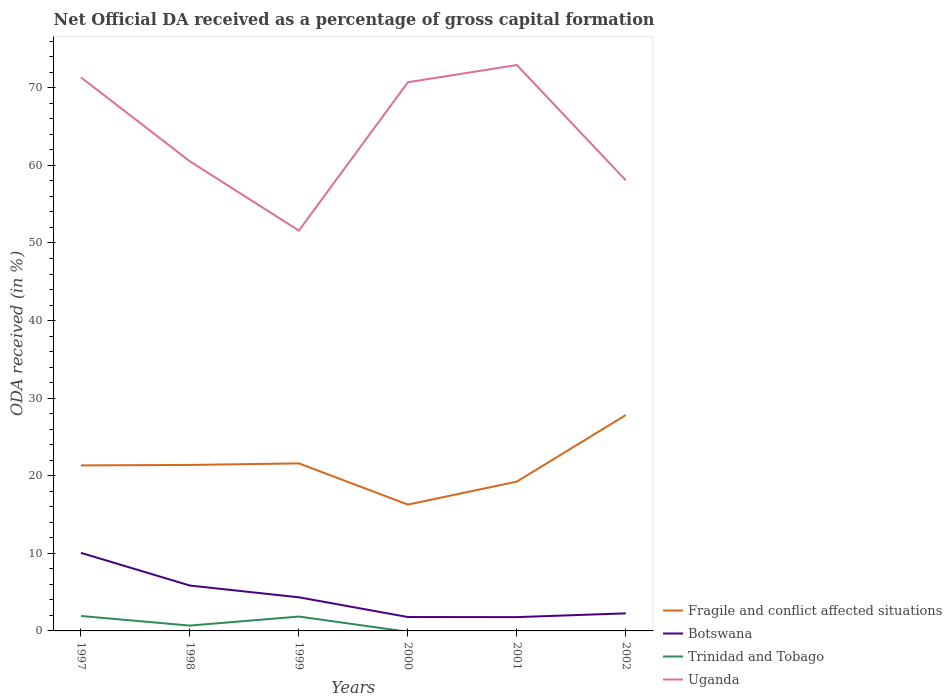How many different coloured lines are there?
Offer a terse response. 4. Across all years, what is the maximum net ODA received in Fragile and conflict affected situations?
Your response must be concise. 16.28. What is the total net ODA received in Uganda in the graph?
Keep it short and to the point. 14.86. What is the difference between the highest and the second highest net ODA received in Botswana?
Make the answer very short. 8.28. What is the difference between the highest and the lowest net ODA received in Trinidad and Tobago?
Your answer should be very brief. 2. How many lines are there?
Make the answer very short. 4. How many years are there in the graph?
Offer a terse response. 6. Does the graph contain grids?
Your answer should be very brief. No. How many legend labels are there?
Provide a succinct answer. 4. What is the title of the graph?
Your response must be concise. Net Official DA received as a percentage of gross capital formation. Does "Europe(developing only)" appear as one of the legend labels in the graph?
Offer a very short reply. No. What is the label or title of the X-axis?
Offer a terse response. Years. What is the label or title of the Y-axis?
Your answer should be compact. ODA received (in %). What is the ODA received (in %) of Fragile and conflict affected situations in 1997?
Offer a very short reply. 21.33. What is the ODA received (in %) in Botswana in 1997?
Provide a short and direct response. 10.06. What is the ODA received (in %) in Trinidad and Tobago in 1997?
Your response must be concise. 1.93. What is the ODA received (in %) of Uganda in 1997?
Your answer should be very brief. 71.34. What is the ODA received (in %) in Fragile and conflict affected situations in 1998?
Provide a short and direct response. 21.39. What is the ODA received (in %) in Botswana in 1998?
Give a very brief answer. 5.85. What is the ODA received (in %) of Trinidad and Tobago in 1998?
Provide a succinct answer. 0.69. What is the ODA received (in %) in Uganda in 1998?
Offer a very short reply. 60.51. What is the ODA received (in %) in Fragile and conflict affected situations in 1999?
Keep it short and to the point. 21.59. What is the ODA received (in %) in Botswana in 1999?
Offer a very short reply. 4.33. What is the ODA received (in %) of Trinidad and Tobago in 1999?
Provide a succinct answer. 1.85. What is the ODA received (in %) of Uganda in 1999?
Provide a short and direct response. 51.59. What is the ODA received (in %) in Fragile and conflict affected situations in 2000?
Keep it short and to the point. 16.28. What is the ODA received (in %) in Botswana in 2000?
Keep it short and to the point. 1.79. What is the ODA received (in %) of Uganda in 2000?
Your answer should be very brief. 70.71. What is the ODA received (in %) of Fragile and conflict affected situations in 2001?
Make the answer very short. 19.24. What is the ODA received (in %) in Botswana in 2001?
Make the answer very short. 1.78. What is the ODA received (in %) in Trinidad and Tobago in 2001?
Your response must be concise. 0. What is the ODA received (in %) in Uganda in 2001?
Keep it short and to the point. 72.93. What is the ODA received (in %) in Fragile and conflict affected situations in 2002?
Provide a short and direct response. 27.82. What is the ODA received (in %) of Botswana in 2002?
Provide a succinct answer. 2.26. What is the ODA received (in %) of Trinidad and Tobago in 2002?
Your answer should be compact. 0. What is the ODA received (in %) in Uganda in 2002?
Your response must be concise. 58.07. Across all years, what is the maximum ODA received (in %) of Fragile and conflict affected situations?
Offer a very short reply. 27.82. Across all years, what is the maximum ODA received (in %) of Botswana?
Provide a succinct answer. 10.06. Across all years, what is the maximum ODA received (in %) of Trinidad and Tobago?
Ensure brevity in your answer.  1.93. Across all years, what is the maximum ODA received (in %) of Uganda?
Keep it short and to the point. 72.93. Across all years, what is the minimum ODA received (in %) in Fragile and conflict affected situations?
Provide a succinct answer. 16.28. Across all years, what is the minimum ODA received (in %) of Botswana?
Your answer should be very brief. 1.78. Across all years, what is the minimum ODA received (in %) in Uganda?
Ensure brevity in your answer.  51.59. What is the total ODA received (in %) in Fragile and conflict affected situations in the graph?
Make the answer very short. 127.66. What is the total ODA received (in %) of Botswana in the graph?
Ensure brevity in your answer.  26.07. What is the total ODA received (in %) of Trinidad and Tobago in the graph?
Your answer should be compact. 4.47. What is the total ODA received (in %) of Uganda in the graph?
Make the answer very short. 385.17. What is the difference between the ODA received (in %) of Fragile and conflict affected situations in 1997 and that in 1998?
Provide a short and direct response. -0.06. What is the difference between the ODA received (in %) in Botswana in 1997 and that in 1998?
Your answer should be compact. 4.22. What is the difference between the ODA received (in %) of Trinidad and Tobago in 1997 and that in 1998?
Provide a succinct answer. 1.24. What is the difference between the ODA received (in %) of Uganda in 1997 and that in 1998?
Offer a very short reply. 10.83. What is the difference between the ODA received (in %) in Fragile and conflict affected situations in 1997 and that in 1999?
Provide a succinct answer. -0.26. What is the difference between the ODA received (in %) in Botswana in 1997 and that in 1999?
Provide a succinct answer. 5.73. What is the difference between the ODA received (in %) in Trinidad and Tobago in 1997 and that in 1999?
Offer a terse response. 0.07. What is the difference between the ODA received (in %) of Uganda in 1997 and that in 1999?
Offer a terse response. 19.75. What is the difference between the ODA received (in %) of Fragile and conflict affected situations in 1997 and that in 2000?
Ensure brevity in your answer.  5.05. What is the difference between the ODA received (in %) in Botswana in 1997 and that in 2000?
Your response must be concise. 8.27. What is the difference between the ODA received (in %) in Uganda in 1997 and that in 2000?
Your answer should be compact. 0.63. What is the difference between the ODA received (in %) of Fragile and conflict affected situations in 1997 and that in 2001?
Make the answer very short. 2.09. What is the difference between the ODA received (in %) of Botswana in 1997 and that in 2001?
Keep it short and to the point. 8.28. What is the difference between the ODA received (in %) in Uganda in 1997 and that in 2001?
Provide a short and direct response. -1.59. What is the difference between the ODA received (in %) in Fragile and conflict affected situations in 1997 and that in 2002?
Offer a terse response. -6.49. What is the difference between the ODA received (in %) in Botswana in 1997 and that in 2002?
Provide a short and direct response. 7.8. What is the difference between the ODA received (in %) of Uganda in 1997 and that in 2002?
Your answer should be very brief. 13.27. What is the difference between the ODA received (in %) of Fragile and conflict affected situations in 1998 and that in 1999?
Offer a terse response. -0.2. What is the difference between the ODA received (in %) of Botswana in 1998 and that in 1999?
Provide a short and direct response. 1.51. What is the difference between the ODA received (in %) in Trinidad and Tobago in 1998 and that in 1999?
Keep it short and to the point. -1.16. What is the difference between the ODA received (in %) of Uganda in 1998 and that in 1999?
Make the answer very short. 8.92. What is the difference between the ODA received (in %) of Fragile and conflict affected situations in 1998 and that in 2000?
Ensure brevity in your answer.  5.11. What is the difference between the ODA received (in %) in Botswana in 1998 and that in 2000?
Make the answer very short. 4.06. What is the difference between the ODA received (in %) in Uganda in 1998 and that in 2000?
Keep it short and to the point. -10.2. What is the difference between the ODA received (in %) of Fragile and conflict affected situations in 1998 and that in 2001?
Make the answer very short. 2.15. What is the difference between the ODA received (in %) in Botswana in 1998 and that in 2001?
Offer a very short reply. 4.07. What is the difference between the ODA received (in %) of Uganda in 1998 and that in 2001?
Provide a short and direct response. -12.42. What is the difference between the ODA received (in %) in Fragile and conflict affected situations in 1998 and that in 2002?
Give a very brief answer. -6.43. What is the difference between the ODA received (in %) in Botswana in 1998 and that in 2002?
Ensure brevity in your answer.  3.58. What is the difference between the ODA received (in %) in Uganda in 1998 and that in 2002?
Give a very brief answer. 2.44. What is the difference between the ODA received (in %) of Fragile and conflict affected situations in 1999 and that in 2000?
Ensure brevity in your answer.  5.31. What is the difference between the ODA received (in %) of Botswana in 1999 and that in 2000?
Provide a short and direct response. 2.54. What is the difference between the ODA received (in %) in Uganda in 1999 and that in 2000?
Provide a short and direct response. -19.12. What is the difference between the ODA received (in %) of Fragile and conflict affected situations in 1999 and that in 2001?
Give a very brief answer. 2.35. What is the difference between the ODA received (in %) in Botswana in 1999 and that in 2001?
Your answer should be very brief. 2.55. What is the difference between the ODA received (in %) in Uganda in 1999 and that in 2001?
Provide a short and direct response. -21.34. What is the difference between the ODA received (in %) in Fragile and conflict affected situations in 1999 and that in 2002?
Give a very brief answer. -6.23. What is the difference between the ODA received (in %) in Botswana in 1999 and that in 2002?
Ensure brevity in your answer.  2.07. What is the difference between the ODA received (in %) of Uganda in 1999 and that in 2002?
Your answer should be very brief. -6.48. What is the difference between the ODA received (in %) of Fragile and conflict affected situations in 2000 and that in 2001?
Keep it short and to the point. -2.96. What is the difference between the ODA received (in %) in Botswana in 2000 and that in 2001?
Your answer should be compact. 0.01. What is the difference between the ODA received (in %) in Uganda in 2000 and that in 2001?
Your answer should be compact. -2.22. What is the difference between the ODA received (in %) of Fragile and conflict affected situations in 2000 and that in 2002?
Give a very brief answer. -11.54. What is the difference between the ODA received (in %) of Botswana in 2000 and that in 2002?
Your answer should be compact. -0.47. What is the difference between the ODA received (in %) of Uganda in 2000 and that in 2002?
Provide a short and direct response. 12.64. What is the difference between the ODA received (in %) in Fragile and conflict affected situations in 2001 and that in 2002?
Keep it short and to the point. -8.58. What is the difference between the ODA received (in %) in Botswana in 2001 and that in 2002?
Your response must be concise. -0.49. What is the difference between the ODA received (in %) in Uganda in 2001 and that in 2002?
Provide a short and direct response. 14.86. What is the difference between the ODA received (in %) in Fragile and conflict affected situations in 1997 and the ODA received (in %) in Botswana in 1998?
Make the answer very short. 15.48. What is the difference between the ODA received (in %) in Fragile and conflict affected situations in 1997 and the ODA received (in %) in Trinidad and Tobago in 1998?
Provide a short and direct response. 20.64. What is the difference between the ODA received (in %) of Fragile and conflict affected situations in 1997 and the ODA received (in %) of Uganda in 1998?
Make the answer very short. -39.18. What is the difference between the ODA received (in %) of Botswana in 1997 and the ODA received (in %) of Trinidad and Tobago in 1998?
Provide a short and direct response. 9.37. What is the difference between the ODA received (in %) of Botswana in 1997 and the ODA received (in %) of Uganda in 1998?
Keep it short and to the point. -50.45. What is the difference between the ODA received (in %) of Trinidad and Tobago in 1997 and the ODA received (in %) of Uganda in 1998?
Provide a succinct answer. -58.59. What is the difference between the ODA received (in %) in Fragile and conflict affected situations in 1997 and the ODA received (in %) in Botswana in 1999?
Provide a short and direct response. 17. What is the difference between the ODA received (in %) in Fragile and conflict affected situations in 1997 and the ODA received (in %) in Trinidad and Tobago in 1999?
Your answer should be compact. 19.48. What is the difference between the ODA received (in %) in Fragile and conflict affected situations in 1997 and the ODA received (in %) in Uganda in 1999?
Offer a very short reply. -30.26. What is the difference between the ODA received (in %) of Botswana in 1997 and the ODA received (in %) of Trinidad and Tobago in 1999?
Your response must be concise. 8.21. What is the difference between the ODA received (in %) of Botswana in 1997 and the ODA received (in %) of Uganda in 1999?
Make the answer very short. -41.53. What is the difference between the ODA received (in %) of Trinidad and Tobago in 1997 and the ODA received (in %) of Uganda in 1999?
Offer a terse response. -49.67. What is the difference between the ODA received (in %) of Fragile and conflict affected situations in 1997 and the ODA received (in %) of Botswana in 2000?
Your response must be concise. 19.54. What is the difference between the ODA received (in %) in Fragile and conflict affected situations in 1997 and the ODA received (in %) in Uganda in 2000?
Keep it short and to the point. -49.38. What is the difference between the ODA received (in %) in Botswana in 1997 and the ODA received (in %) in Uganda in 2000?
Make the answer very short. -60.65. What is the difference between the ODA received (in %) in Trinidad and Tobago in 1997 and the ODA received (in %) in Uganda in 2000?
Your response must be concise. -68.79. What is the difference between the ODA received (in %) in Fragile and conflict affected situations in 1997 and the ODA received (in %) in Botswana in 2001?
Your answer should be very brief. 19.55. What is the difference between the ODA received (in %) in Fragile and conflict affected situations in 1997 and the ODA received (in %) in Uganda in 2001?
Your response must be concise. -51.6. What is the difference between the ODA received (in %) of Botswana in 1997 and the ODA received (in %) of Uganda in 2001?
Give a very brief answer. -62.87. What is the difference between the ODA received (in %) in Trinidad and Tobago in 1997 and the ODA received (in %) in Uganda in 2001?
Provide a succinct answer. -71.01. What is the difference between the ODA received (in %) in Fragile and conflict affected situations in 1997 and the ODA received (in %) in Botswana in 2002?
Your answer should be very brief. 19.07. What is the difference between the ODA received (in %) of Fragile and conflict affected situations in 1997 and the ODA received (in %) of Uganda in 2002?
Give a very brief answer. -36.74. What is the difference between the ODA received (in %) of Botswana in 1997 and the ODA received (in %) of Uganda in 2002?
Offer a very short reply. -48.01. What is the difference between the ODA received (in %) of Trinidad and Tobago in 1997 and the ODA received (in %) of Uganda in 2002?
Ensure brevity in your answer.  -56.14. What is the difference between the ODA received (in %) of Fragile and conflict affected situations in 1998 and the ODA received (in %) of Botswana in 1999?
Keep it short and to the point. 17.06. What is the difference between the ODA received (in %) of Fragile and conflict affected situations in 1998 and the ODA received (in %) of Trinidad and Tobago in 1999?
Ensure brevity in your answer.  19.54. What is the difference between the ODA received (in %) in Fragile and conflict affected situations in 1998 and the ODA received (in %) in Uganda in 1999?
Offer a terse response. -30.2. What is the difference between the ODA received (in %) of Botswana in 1998 and the ODA received (in %) of Trinidad and Tobago in 1999?
Ensure brevity in your answer.  3.99. What is the difference between the ODA received (in %) in Botswana in 1998 and the ODA received (in %) in Uganda in 1999?
Offer a very short reply. -45.75. What is the difference between the ODA received (in %) in Trinidad and Tobago in 1998 and the ODA received (in %) in Uganda in 1999?
Make the answer very short. -50.91. What is the difference between the ODA received (in %) in Fragile and conflict affected situations in 1998 and the ODA received (in %) in Botswana in 2000?
Your answer should be very brief. 19.6. What is the difference between the ODA received (in %) of Fragile and conflict affected situations in 1998 and the ODA received (in %) of Uganda in 2000?
Give a very brief answer. -49.32. What is the difference between the ODA received (in %) of Botswana in 1998 and the ODA received (in %) of Uganda in 2000?
Provide a succinct answer. -64.87. What is the difference between the ODA received (in %) of Trinidad and Tobago in 1998 and the ODA received (in %) of Uganda in 2000?
Provide a succinct answer. -70.03. What is the difference between the ODA received (in %) of Fragile and conflict affected situations in 1998 and the ODA received (in %) of Botswana in 2001?
Offer a terse response. 19.61. What is the difference between the ODA received (in %) of Fragile and conflict affected situations in 1998 and the ODA received (in %) of Uganda in 2001?
Give a very brief answer. -51.54. What is the difference between the ODA received (in %) of Botswana in 1998 and the ODA received (in %) of Uganda in 2001?
Your answer should be compact. -67.09. What is the difference between the ODA received (in %) of Trinidad and Tobago in 1998 and the ODA received (in %) of Uganda in 2001?
Offer a very short reply. -72.24. What is the difference between the ODA received (in %) in Fragile and conflict affected situations in 1998 and the ODA received (in %) in Botswana in 2002?
Your answer should be compact. 19.13. What is the difference between the ODA received (in %) in Fragile and conflict affected situations in 1998 and the ODA received (in %) in Uganda in 2002?
Offer a terse response. -36.68. What is the difference between the ODA received (in %) in Botswana in 1998 and the ODA received (in %) in Uganda in 2002?
Your answer should be compact. -52.22. What is the difference between the ODA received (in %) of Trinidad and Tobago in 1998 and the ODA received (in %) of Uganda in 2002?
Your answer should be compact. -57.38. What is the difference between the ODA received (in %) of Fragile and conflict affected situations in 1999 and the ODA received (in %) of Botswana in 2000?
Offer a terse response. 19.8. What is the difference between the ODA received (in %) of Fragile and conflict affected situations in 1999 and the ODA received (in %) of Uganda in 2000?
Offer a terse response. -49.12. What is the difference between the ODA received (in %) in Botswana in 1999 and the ODA received (in %) in Uganda in 2000?
Offer a very short reply. -66.38. What is the difference between the ODA received (in %) of Trinidad and Tobago in 1999 and the ODA received (in %) of Uganda in 2000?
Offer a terse response. -68.86. What is the difference between the ODA received (in %) of Fragile and conflict affected situations in 1999 and the ODA received (in %) of Botswana in 2001?
Give a very brief answer. 19.81. What is the difference between the ODA received (in %) in Fragile and conflict affected situations in 1999 and the ODA received (in %) in Uganda in 2001?
Give a very brief answer. -51.34. What is the difference between the ODA received (in %) of Botswana in 1999 and the ODA received (in %) of Uganda in 2001?
Your answer should be compact. -68.6. What is the difference between the ODA received (in %) of Trinidad and Tobago in 1999 and the ODA received (in %) of Uganda in 2001?
Make the answer very short. -71.08. What is the difference between the ODA received (in %) of Fragile and conflict affected situations in 1999 and the ODA received (in %) of Botswana in 2002?
Keep it short and to the point. 19.33. What is the difference between the ODA received (in %) of Fragile and conflict affected situations in 1999 and the ODA received (in %) of Uganda in 2002?
Offer a terse response. -36.48. What is the difference between the ODA received (in %) of Botswana in 1999 and the ODA received (in %) of Uganda in 2002?
Ensure brevity in your answer.  -53.74. What is the difference between the ODA received (in %) in Trinidad and Tobago in 1999 and the ODA received (in %) in Uganda in 2002?
Keep it short and to the point. -56.22. What is the difference between the ODA received (in %) of Fragile and conflict affected situations in 2000 and the ODA received (in %) of Botswana in 2001?
Provide a short and direct response. 14.5. What is the difference between the ODA received (in %) of Fragile and conflict affected situations in 2000 and the ODA received (in %) of Uganda in 2001?
Give a very brief answer. -56.65. What is the difference between the ODA received (in %) of Botswana in 2000 and the ODA received (in %) of Uganda in 2001?
Make the answer very short. -71.14. What is the difference between the ODA received (in %) of Fragile and conflict affected situations in 2000 and the ODA received (in %) of Botswana in 2002?
Make the answer very short. 14.01. What is the difference between the ODA received (in %) in Fragile and conflict affected situations in 2000 and the ODA received (in %) in Uganda in 2002?
Ensure brevity in your answer.  -41.79. What is the difference between the ODA received (in %) in Botswana in 2000 and the ODA received (in %) in Uganda in 2002?
Make the answer very short. -56.28. What is the difference between the ODA received (in %) in Fragile and conflict affected situations in 2001 and the ODA received (in %) in Botswana in 2002?
Offer a terse response. 16.98. What is the difference between the ODA received (in %) in Fragile and conflict affected situations in 2001 and the ODA received (in %) in Uganda in 2002?
Your answer should be very brief. -38.83. What is the difference between the ODA received (in %) of Botswana in 2001 and the ODA received (in %) of Uganda in 2002?
Make the answer very short. -56.29. What is the average ODA received (in %) in Fragile and conflict affected situations per year?
Ensure brevity in your answer.  21.28. What is the average ODA received (in %) of Botswana per year?
Your answer should be very brief. 4.35. What is the average ODA received (in %) in Trinidad and Tobago per year?
Your answer should be compact. 0.74. What is the average ODA received (in %) of Uganda per year?
Make the answer very short. 64.19. In the year 1997, what is the difference between the ODA received (in %) in Fragile and conflict affected situations and ODA received (in %) in Botswana?
Your response must be concise. 11.27. In the year 1997, what is the difference between the ODA received (in %) in Fragile and conflict affected situations and ODA received (in %) in Trinidad and Tobago?
Make the answer very short. 19.41. In the year 1997, what is the difference between the ODA received (in %) in Fragile and conflict affected situations and ODA received (in %) in Uganda?
Ensure brevity in your answer.  -50.01. In the year 1997, what is the difference between the ODA received (in %) of Botswana and ODA received (in %) of Trinidad and Tobago?
Your response must be concise. 8.14. In the year 1997, what is the difference between the ODA received (in %) of Botswana and ODA received (in %) of Uganda?
Keep it short and to the point. -61.28. In the year 1997, what is the difference between the ODA received (in %) of Trinidad and Tobago and ODA received (in %) of Uganda?
Offer a terse response. -69.41. In the year 1998, what is the difference between the ODA received (in %) in Fragile and conflict affected situations and ODA received (in %) in Botswana?
Make the answer very short. 15.55. In the year 1998, what is the difference between the ODA received (in %) of Fragile and conflict affected situations and ODA received (in %) of Trinidad and Tobago?
Provide a short and direct response. 20.7. In the year 1998, what is the difference between the ODA received (in %) of Fragile and conflict affected situations and ODA received (in %) of Uganda?
Ensure brevity in your answer.  -39.12. In the year 1998, what is the difference between the ODA received (in %) of Botswana and ODA received (in %) of Trinidad and Tobago?
Offer a very short reply. 5.16. In the year 1998, what is the difference between the ODA received (in %) of Botswana and ODA received (in %) of Uganda?
Make the answer very short. -54.67. In the year 1998, what is the difference between the ODA received (in %) in Trinidad and Tobago and ODA received (in %) in Uganda?
Give a very brief answer. -59.83. In the year 1999, what is the difference between the ODA received (in %) of Fragile and conflict affected situations and ODA received (in %) of Botswana?
Your answer should be very brief. 17.26. In the year 1999, what is the difference between the ODA received (in %) of Fragile and conflict affected situations and ODA received (in %) of Trinidad and Tobago?
Ensure brevity in your answer.  19.74. In the year 1999, what is the difference between the ODA received (in %) in Fragile and conflict affected situations and ODA received (in %) in Uganda?
Your response must be concise. -30. In the year 1999, what is the difference between the ODA received (in %) of Botswana and ODA received (in %) of Trinidad and Tobago?
Give a very brief answer. 2.48. In the year 1999, what is the difference between the ODA received (in %) of Botswana and ODA received (in %) of Uganda?
Offer a very short reply. -47.26. In the year 1999, what is the difference between the ODA received (in %) of Trinidad and Tobago and ODA received (in %) of Uganda?
Give a very brief answer. -49.74. In the year 2000, what is the difference between the ODA received (in %) in Fragile and conflict affected situations and ODA received (in %) in Botswana?
Offer a terse response. 14.49. In the year 2000, what is the difference between the ODA received (in %) of Fragile and conflict affected situations and ODA received (in %) of Uganda?
Your response must be concise. -54.43. In the year 2000, what is the difference between the ODA received (in %) in Botswana and ODA received (in %) in Uganda?
Give a very brief answer. -68.92. In the year 2001, what is the difference between the ODA received (in %) of Fragile and conflict affected situations and ODA received (in %) of Botswana?
Keep it short and to the point. 17.46. In the year 2001, what is the difference between the ODA received (in %) of Fragile and conflict affected situations and ODA received (in %) of Uganda?
Your answer should be very brief. -53.69. In the year 2001, what is the difference between the ODA received (in %) in Botswana and ODA received (in %) in Uganda?
Your answer should be compact. -71.15. In the year 2002, what is the difference between the ODA received (in %) of Fragile and conflict affected situations and ODA received (in %) of Botswana?
Provide a short and direct response. 25.56. In the year 2002, what is the difference between the ODA received (in %) in Fragile and conflict affected situations and ODA received (in %) in Uganda?
Provide a succinct answer. -30.25. In the year 2002, what is the difference between the ODA received (in %) in Botswana and ODA received (in %) in Uganda?
Your answer should be very brief. -55.81. What is the ratio of the ODA received (in %) in Fragile and conflict affected situations in 1997 to that in 1998?
Your response must be concise. 1. What is the ratio of the ODA received (in %) in Botswana in 1997 to that in 1998?
Your answer should be very brief. 1.72. What is the ratio of the ODA received (in %) in Trinidad and Tobago in 1997 to that in 1998?
Keep it short and to the point. 2.8. What is the ratio of the ODA received (in %) in Uganda in 1997 to that in 1998?
Provide a succinct answer. 1.18. What is the ratio of the ODA received (in %) of Fragile and conflict affected situations in 1997 to that in 1999?
Provide a short and direct response. 0.99. What is the ratio of the ODA received (in %) in Botswana in 1997 to that in 1999?
Offer a very short reply. 2.32. What is the ratio of the ODA received (in %) of Trinidad and Tobago in 1997 to that in 1999?
Provide a short and direct response. 1.04. What is the ratio of the ODA received (in %) in Uganda in 1997 to that in 1999?
Provide a succinct answer. 1.38. What is the ratio of the ODA received (in %) of Fragile and conflict affected situations in 1997 to that in 2000?
Your answer should be very brief. 1.31. What is the ratio of the ODA received (in %) in Botswana in 1997 to that in 2000?
Your answer should be compact. 5.62. What is the ratio of the ODA received (in %) in Uganda in 1997 to that in 2000?
Ensure brevity in your answer.  1.01. What is the ratio of the ODA received (in %) in Fragile and conflict affected situations in 1997 to that in 2001?
Your answer should be very brief. 1.11. What is the ratio of the ODA received (in %) of Botswana in 1997 to that in 2001?
Your answer should be very brief. 5.66. What is the ratio of the ODA received (in %) in Uganda in 1997 to that in 2001?
Your answer should be compact. 0.98. What is the ratio of the ODA received (in %) of Fragile and conflict affected situations in 1997 to that in 2002?
Offer a very short reply. 0.77. What is the ratio of the ODA received (in %) in Botswana in 1997 to that in 2002?
Your response must be concise. 4.44. What is the ratio of the ODA received (in %) in Uganda in 1997 to that in 2002?
Your answer should be very brief. 1.23. What is the ratio of the ODA received (in %) in Fragile and conflict affected situations in 1998 to that in 1999?
Provide a succinct answer. 0.99. What is the ratio of the ODA received (in %) of Botswana in 1998 to that in 1999?
Give a very brief answer. 1.35. What is the ratio of the ODA received (in %) of Trinidad and Tobago in 1998 to that in 1999?
Provide a short and direct response. 0.37. What is the ratio of the ODA received (in %) in Uganda in 1998 to that in 1999?
Offer a terse response. 1.17. What is the ratio of the ODA received (in %) in Fragile and conflict affected situations in 1998 to that in 2000?
Ensure brevity in your answer.  1.31. What is the ratio of the ODA received (in %) in Botswana in 1998 to that in 2000?
Make the answer very short. 3.27. What is the ratio of the ODA received (in %) in Uganda in 1998 to that in 2000?
Keep it short and to the point. 0.86. What is the ratio of the ODA received (in %) in Fragile and conflict affected situations in 1998 to that in 2001?
Provide a short and direct response. 1.11. What is the ratio of the ODA received (in %) in Botswana in 1998 to that in 2001?
Make the answer very short. 3.29. What is the ratio of the ODA received (in %) in Uganda in 1998 to that in 2001?
Offer a terse response. 0.83. What is the ratio of the ODA received (in %) of Fragile and conflict affected situations in 1998 to that in 2002?
Offer a terse response. 0.77. What is the ratio of the ODA received (in %) of Botswana in 1998 to that in 2002?
Give a very brief answer. 2.58. What is the ratio of the ODA received (in %) in Uganda in 1998 to that in 2002?
Offer a terse response. 1.04. What is the ratio of the ODA received (in %) in Fragile and conflict affected situations in 1999 to that in 2000?
Offer a very short reply. 1.33. What is the ratio of the ODA received (in %) of Botswana in 1999 to that in 2000?
Give a very brief answer. 2.42. What is the ratio of the ODA received (in %) in Uganda in 1999 to that in 2000?
Your response must be concise. 0.73. What is the ratio of the ODA received (in %) in Fragile and conflict affected situations in 1999 to that in 2001?
Provide a short and direct response. 1.12. What is the ratio of the ODA received (in %) in Botswana in 1999 to that in 2001?
Give a very brief answer. 2.44. What is the ratio of the ODA received (in %) in Uganda in 1999 to that in 2001?
Provide a succinct answer. 0.71. What is the ratio of the ODA received (in %) in Fragile and conflict affected situations in 1999 to that in 2002?
Make the answer very short. 0.78. What is the ratio of the ODA received (in %) in Botswana in 1999 to that in 2002?
Offer a terse response. 1.91. What is the ratio of the ODA received (in %) of Uganda in 1999 to that in 2002?
Offer a very short reply. 0.89. What is the ratio of the ODA received (in %) in Fragile and conflict affected situations in 2000 to that in 2001?
Offer a terse response. 0.85. What is the ratio of the ODA received (in %) in Uganda in 2000 to that in 2001?
Make the answer very short. 0.97. What is the ratio of the ODA received (in %) of Fragile and conflict affected situations in 2000 to that in 2002?
Offer a very short reply. 0.59. What is the ratio of the ODA received (in %) in Botswana in 2000 to that in 2002?
Ensure brevity in your answer.  0.79. What is the ratio of the ODA received (in %) in Uganda in 2000 to that in 2002?
Your answer should be compact. 1.22. What is the ratio of the ODA received (in %) in Fragile and conflict affected situations in 2001 to that in 2002?
Ensure brevity in your answer.  0.69. What is the ratio of the ODA received (in %) in Botswana in 2001 to that in 2002?
Keep it short and to the point. 0.79. What is the ratio of the ODA received (in %) of Uganda in 2001 to that in 2002?
Offer a very short reply. 1.26. What is the difference between the highest and the second highest ODA received (in %) of Fragile and conflict affected situations?
Provide a short and direct response. 6.23. What is the difference between the highest and the second highest ODA received (in %) of Botswana?
Give a very brief answer. 4.22. What is the difference between the highest and the second highest ODA received (in %) of Trinidad and Tobago?
Your answer should be very brief. 0.07. What is the difference between the highest and the second highest ODA received (in %) in Uganda?
Your response must be concise. 1.59. What is the difference between the highest and the lowest ODA received (in %) in Fragile and conflict affected situations?
Make the answer very short. 11.54. What is the difference between the highest and the lowest ODA received (in %) of Botswana?
Your answer should be very brief. 8.28. What is the difference between the highest and the lowest ODA received (in %) in Trinidad and Tobago?
Keep it short and to the point. 1.93. What is the difference between the highest and the lowest ODA received (in %) of Uganda?
Offer a very short reply. 21.34. 